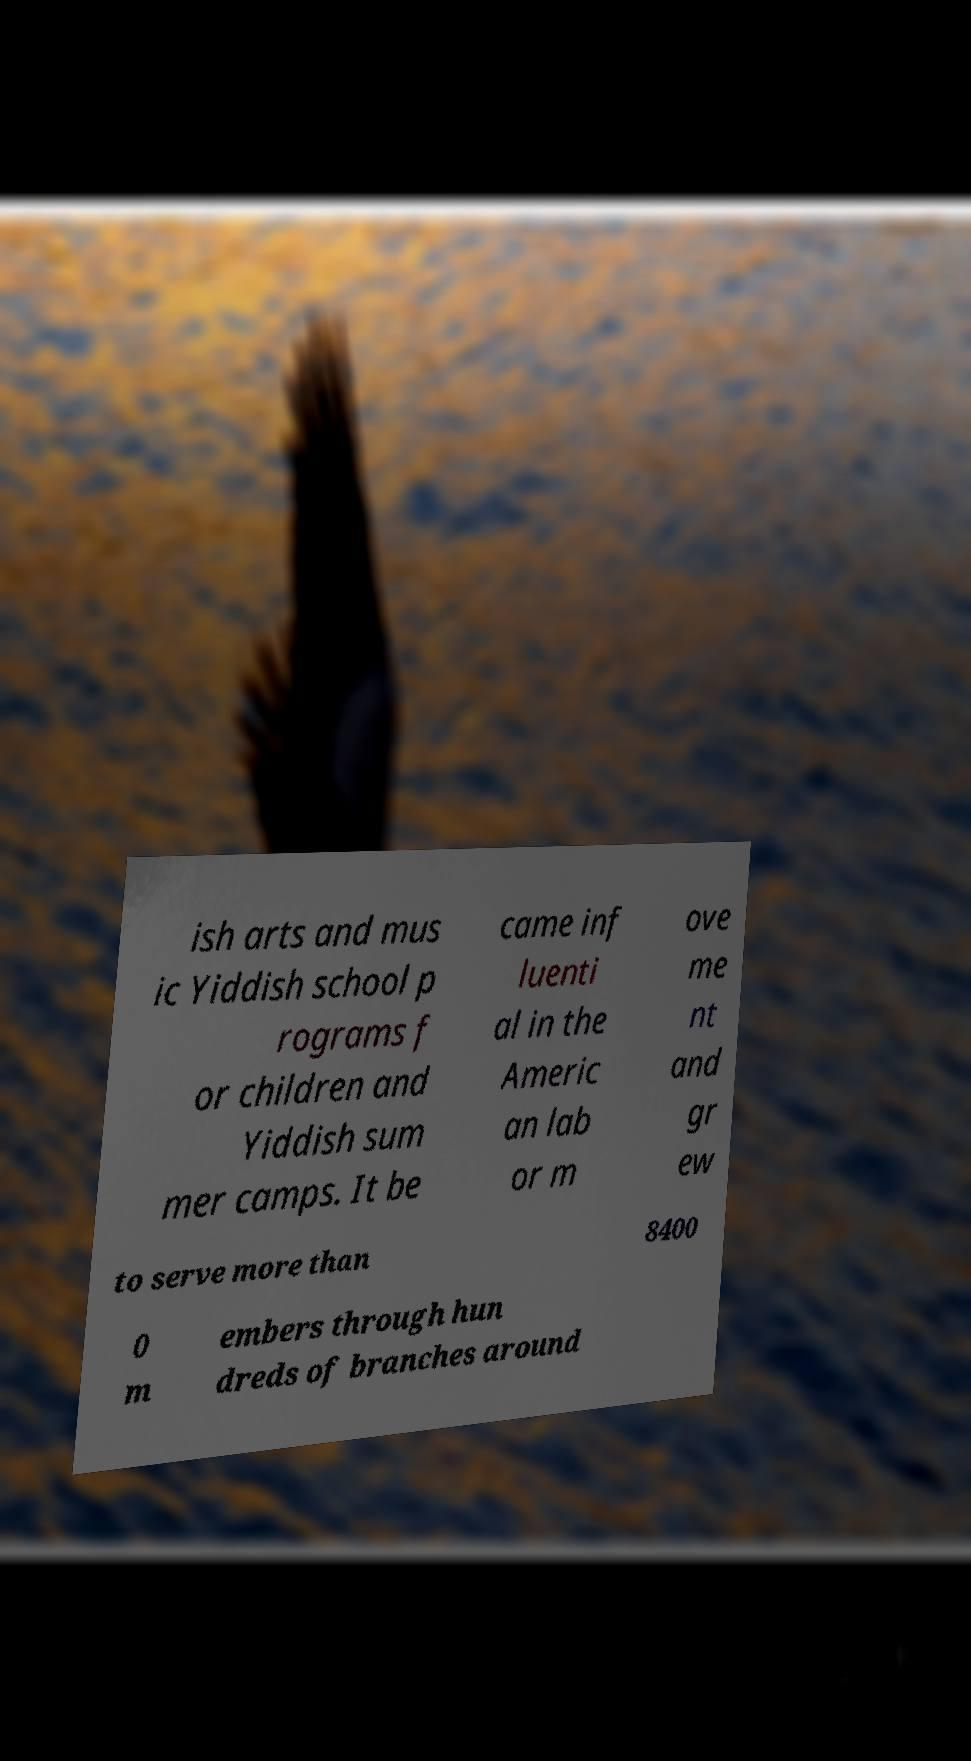Can you accurately transcribe the text from the provided image for me? ish arts and mus ic Yiddish school p rograms f or children and Yiddish sum mer camps. It be came inf luenti al in the Americ an lab or m ove me nt and gr ew to serve more than 8400 0 m embers through hun dreds of branches around 